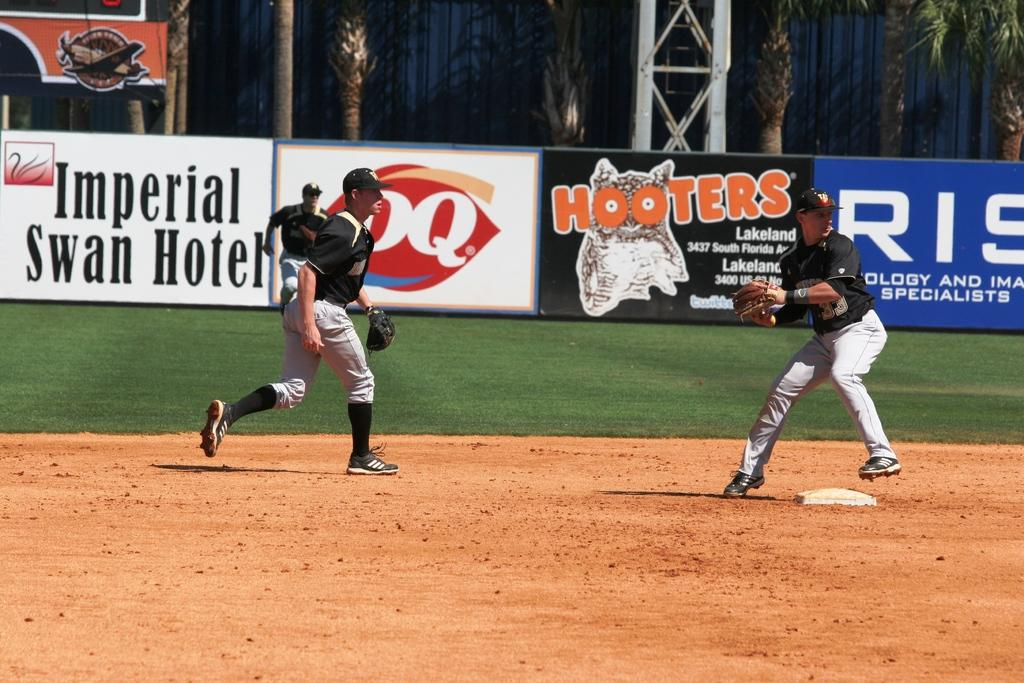Provide a one-sentence caption for the provided image. Baseball players playing in front of an ad for Hooters. 